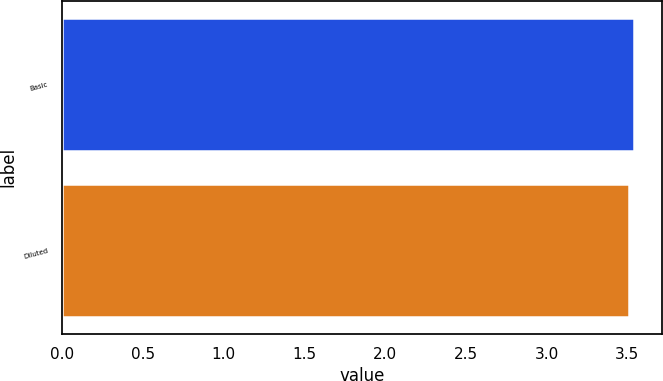Convert chart to OTSL. <chart><loc_0><loc_0><loc_500><loc_500><bar_chart><fcel>Basic<fcel>Diluted<nl><fcel>3.54<fcel>3.51<nl></chart> 